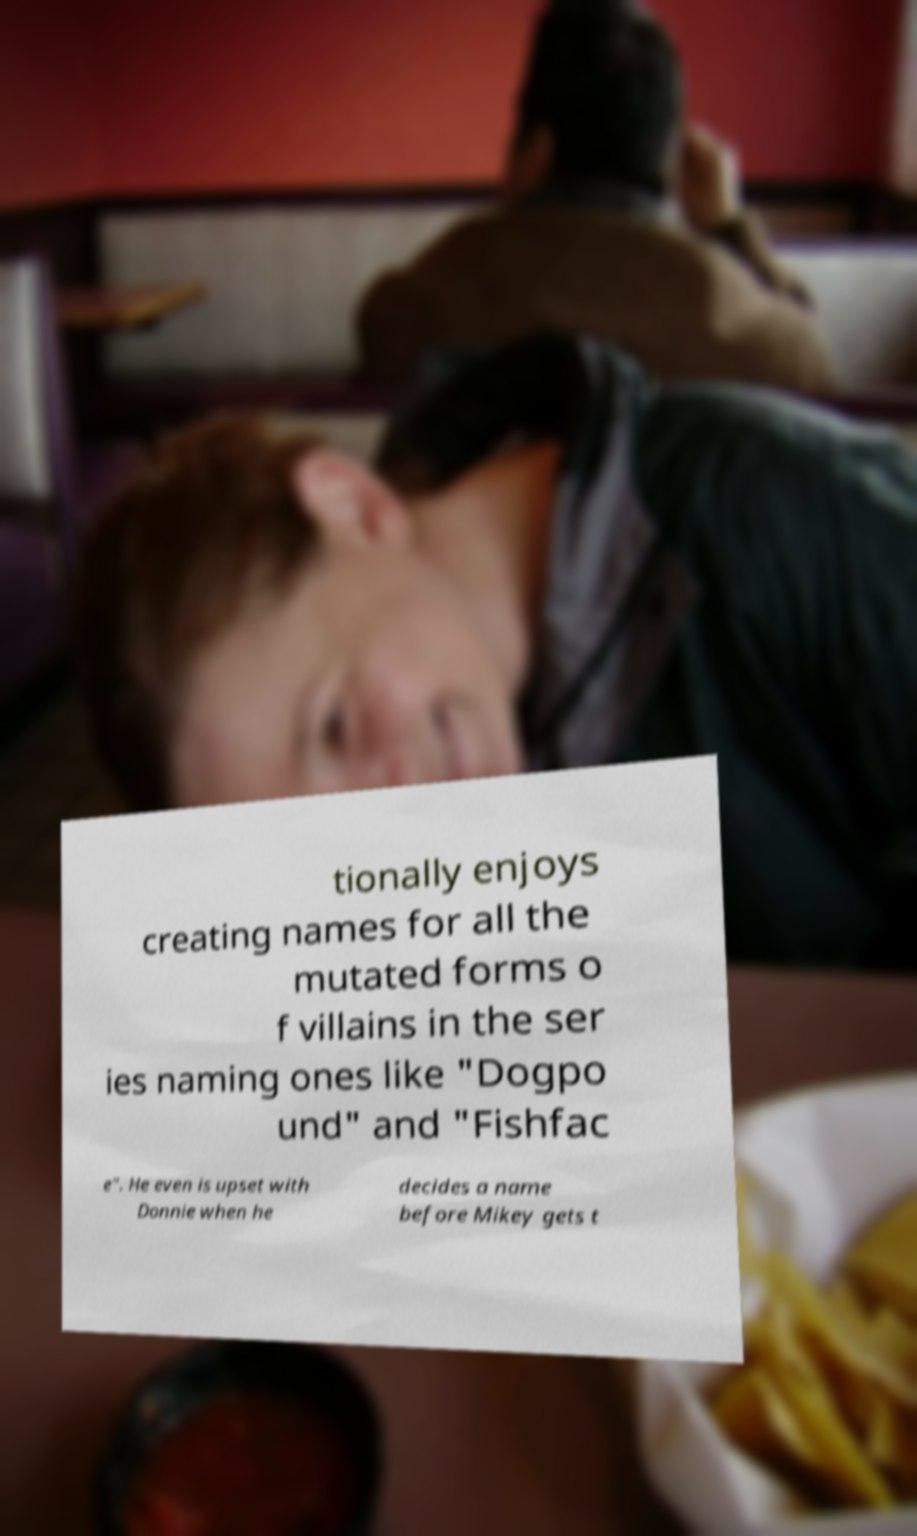Could you assist in decoding the text presented in this image and type it out clearly? tionally enjoys creating names for all the mutated forms o f villains in the ser ies naming ones like "Dogpo und" and "Fishfac e". He even is upset with Donnie when he decides a name before Mikey gets t 